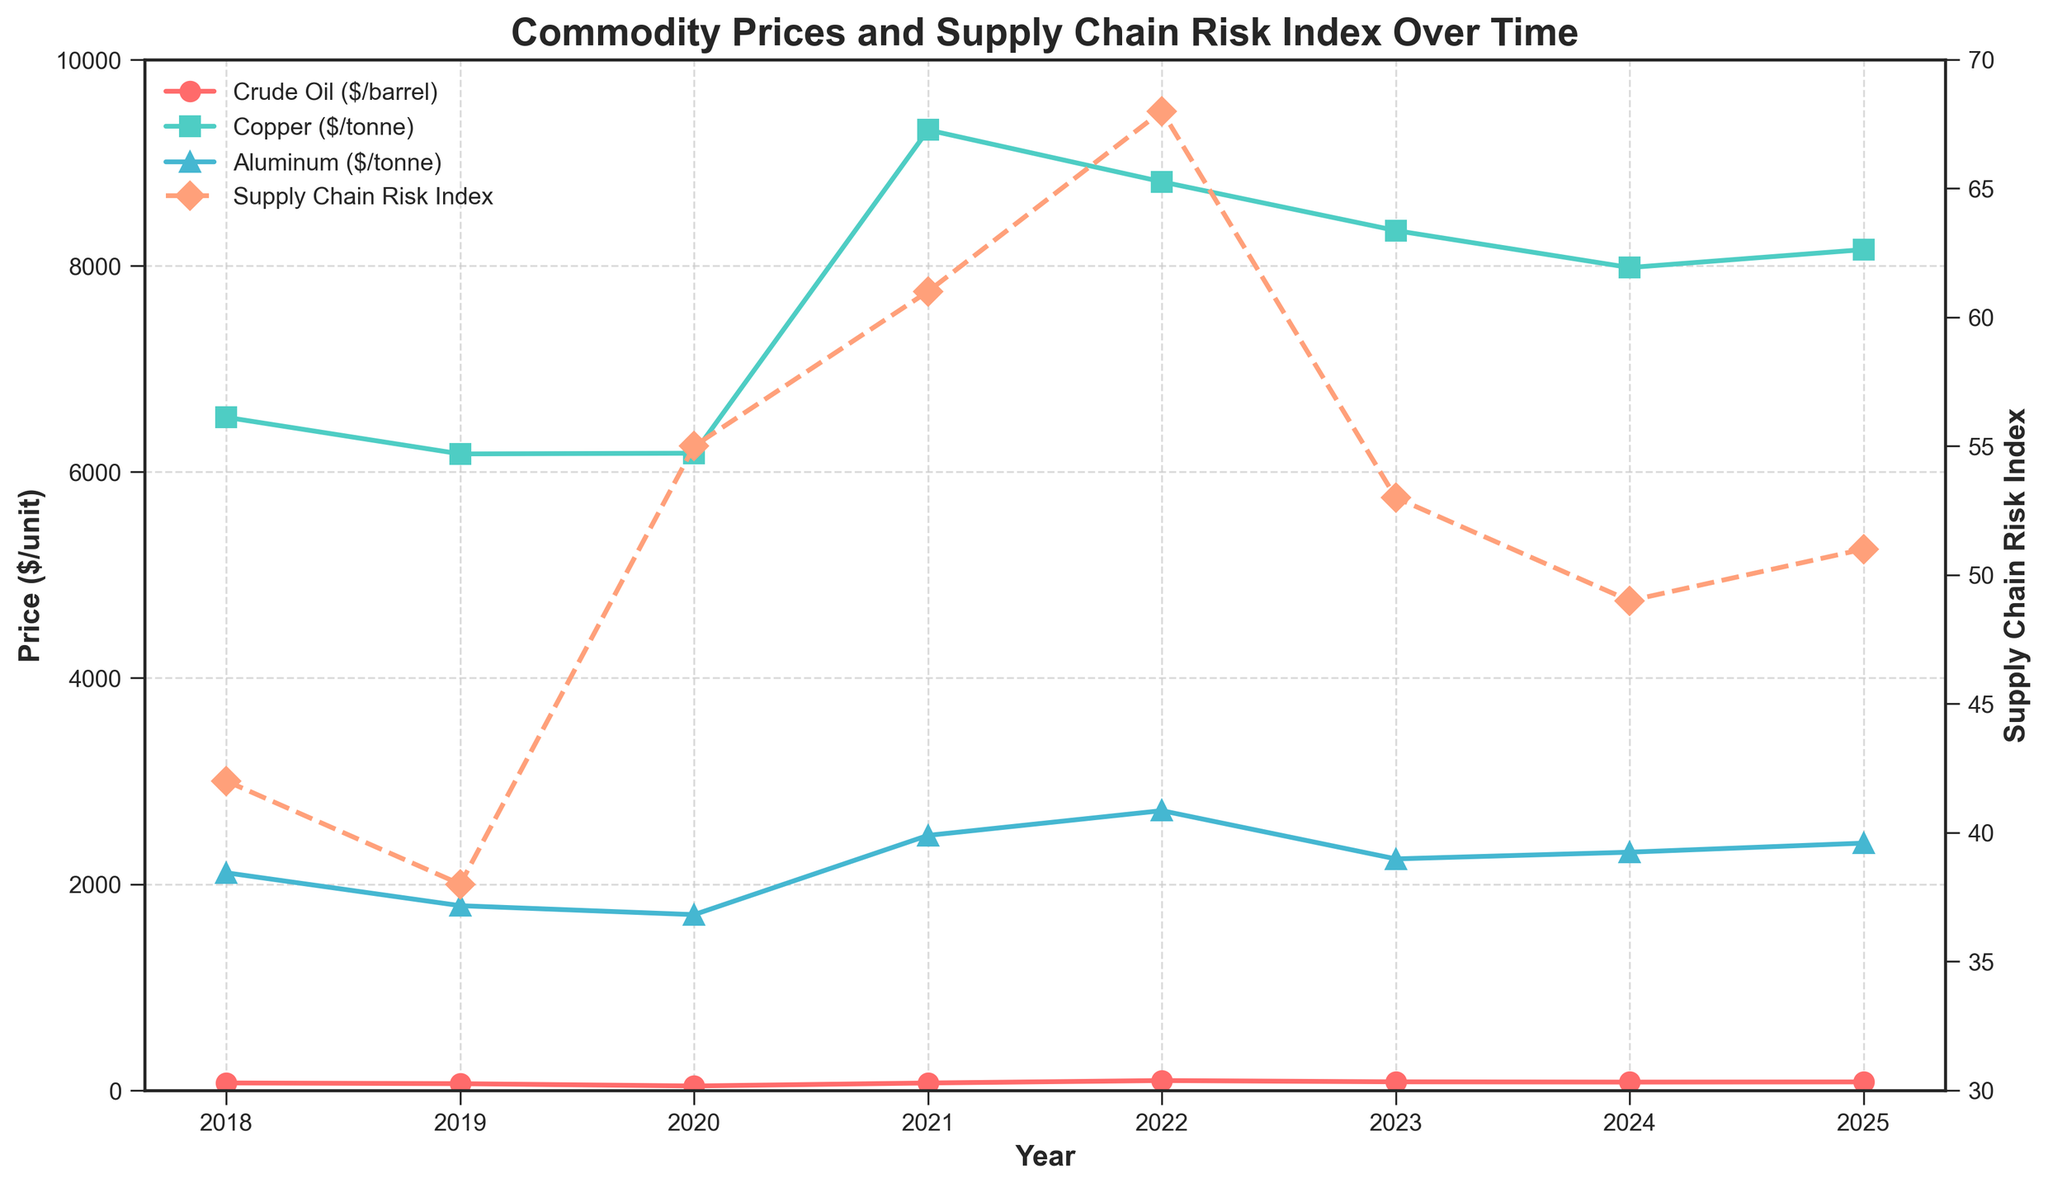Which commodity had the highest price increase from 2020 to 2021? The prices in 2020 were Crude Oil: $41.96, Copper: $6181, Aluminum: $1704. The prices in 2021 were Crude Oil: $70.89, Copper: $9317, Aluminum: $2473. Calculating the differences: Crude Oil: $28.93, Copper: $3136, Aluminum: $769. Copper had the highest increase.
Answer: Copper What is the average Supply Chain Risk Index over the period from 2018 to 2025? The Supply Chain Risk Index values are 42, 38, 55, 61, 68, 53, 49, 51. Summing these up gives 417. Dividing by the number of years (8) gives the average: 417 / 8 ≈ 52.125
Answer: 52.1 In which year did Crude Oil price reach its peak within the given period? Observing the Crude Oil prices over the years, the highest value is $94.53 in 2022. Hence, 2022 is the peak year.
Answer: 2022 What is the difference in the Supply Chain Risk Index between 2020 and 2022? The Supply Chain Risk Index in 2020 is 55 and in 2022 is 68. The difference is 68 - 55 = 13.
Answer: 13 Was the trend of Aluminum prices increasing, decreasing, or stable from 2021 to 2024? Reviewing the Aluminum prices: $2473 (2021), $2713 (2022), $2245 (2023), $2310 (2024). The trend shows an increase from 2021 to 2022, then a decrease in 2023, and a slight increase in 2024, making it overall decreasing.
Answer: Decreasing Which year experienced the highest Supply Chain Risk Index? The highest Supply Chain Risk Index value is 68, occurring in 2022.
Answer: 2022 How did the Supply Chain Risk Index change from 2019 to 2020? The Supply Chain Risk Index in 2019 is 38 and in 2020 is 55. The change is 55 - 38 = 17, indicating an increase.
Answer: Increased by 17 Is there any year where all three commodity prices moved in the same direction (either all increased or all decreased)? Comparing year-on-year changes:
- 2018-2019: all decreased
- 2019-2020: Crude Oil and Aluminum decreased, Copper increased
- 2020-2021: all increased
- 2021-2022: Crude Oil and Aluminum increased, Copper decreased
- 2022-2023: all decreased
- 2023-2024: all decreased
Both 2018-2019 and 2022-2023 saw all decreasing, and 2020-2021 saw all increasing.
Answer: Yes, 2018-2019, 2022-2023, 2020-2021 How much did the Copper price change from its lowest point to its highest point? The lowest Copper price was $6174 in 2019 and the highest was $9317 in 2021. The difference is 9317 - 6174 = 3143.
Answer: 3143 Given the data, what can be inferred about the relationship between the Supply Chain Risk Index and Crude Oil prices from 2020 to 2022? From 2020 to 2022, both Crude Oil prices and the Supply Chain Risk Index show an overall increase: Crude Oil goes from $41.96 (2020) to $94.53 (2022); the Index goes from 55 (2020) to 68 (2022). This suggests a potential correlation where higher Crude Oil prices may increase supply chain risks.
Answer: Positive correlation 